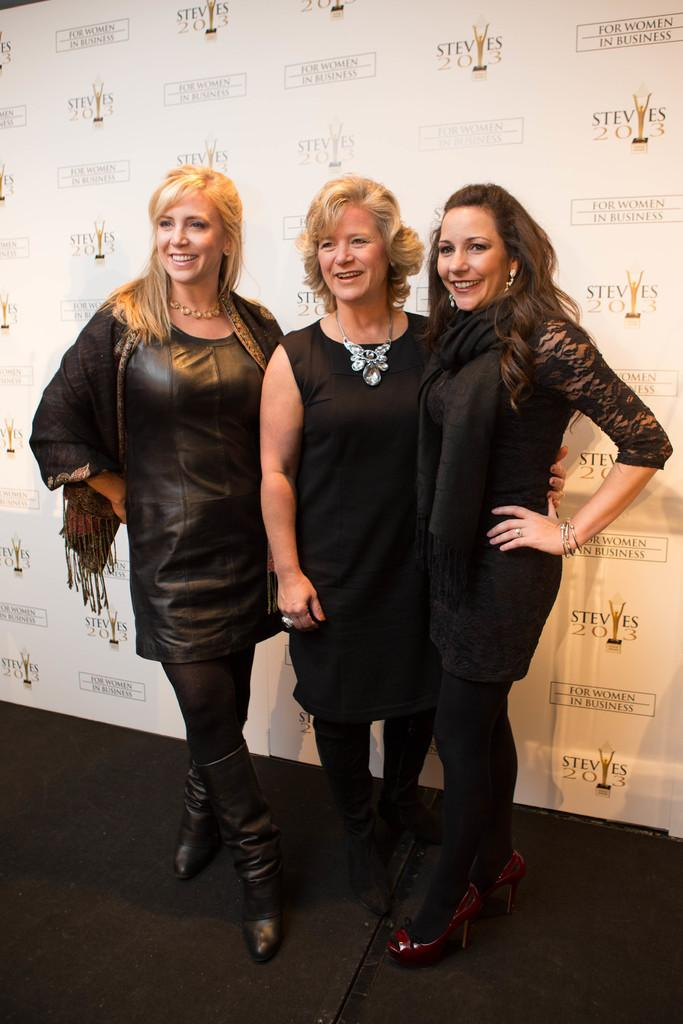How many women are present in the image? There are three women in the image. What are the women doing in the image? The women are standing on the floor and smiling. What can be seen in the background of the image? There is a hoarding in the background of the image. What type of icicle can be seen hanging from the women's hair in the image? There is no icicle present in the image; the women are not depicted with any icicles in their hair. 